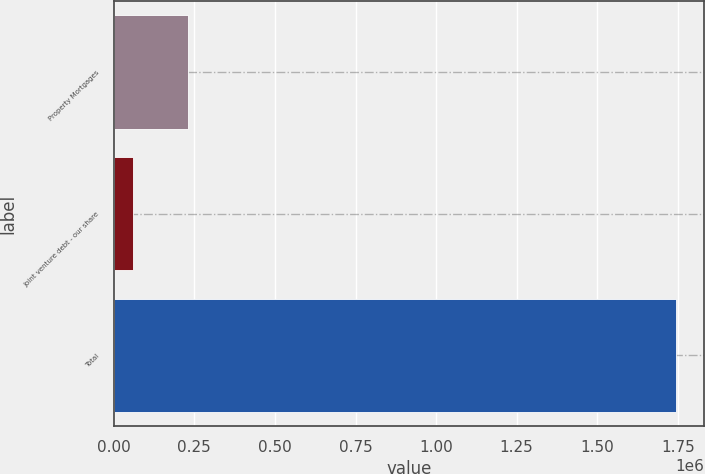Convert chart. <chart><loc_0><loc_0><loc_500><loc_500><bar_chart><fcel>Property Mortgages<fcel>Joint venture debt - our share<fcel>Total<nl><fcel>229155<fcel>60759<fcel>1.74472e+06<nl></chart> 